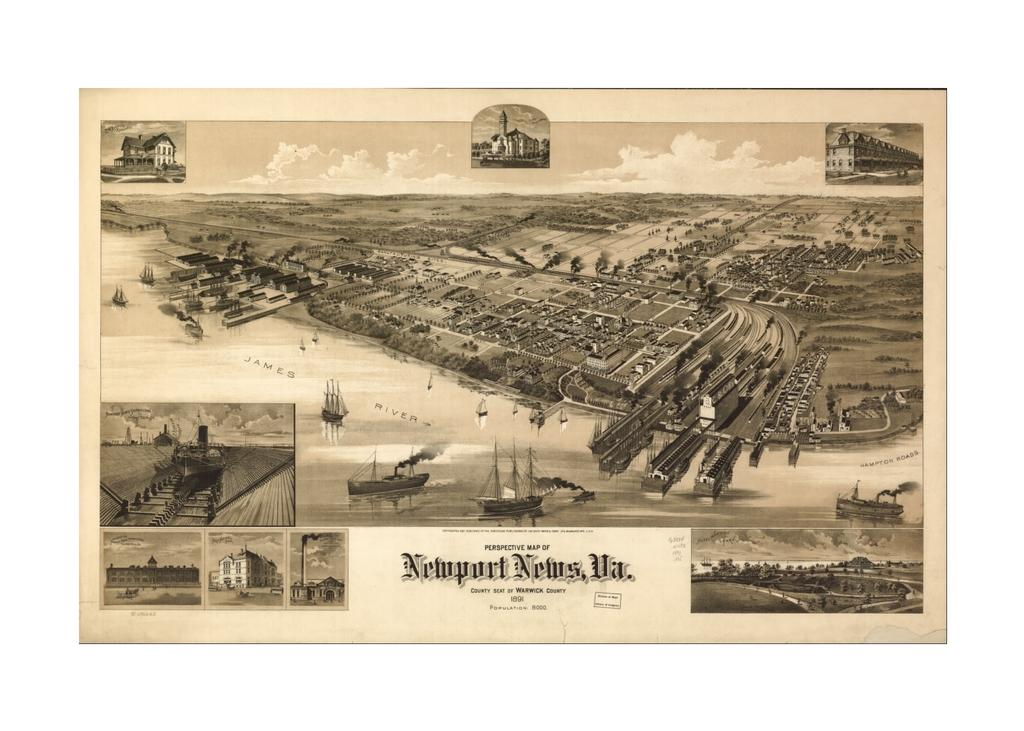<image>
Describe the image concisely. A black and white photograph with Newport News on the bottom. 